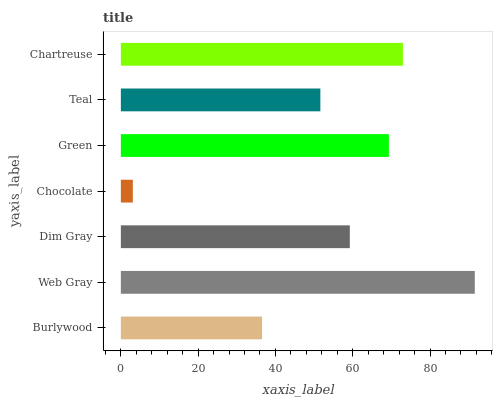Is Chocolate the minimum?
Answer yes or no. Yes. Is Web Gray the maximum?
Answer yes or no. Yes. Is Dim Gray the minimum?
Answer yes or no. No. Is Dim Gray the maximum?
Answer yes or no. No. Is Web Gray greater than Dim Gray?
Answer yes or no. Yes. Is Dim Gray less than Web Gray?
Answer yes or no. Yes. Is Dim Gray greater than Web Gray?
Answer yes or no. No. Is Web Gray less than Dim Gray?
Answer yes or no. No. Is Dim Gray the high median?
Answer yes or no. Yes. Is Dim Gray the low median?
Answer yes or no. Yes. Is Chartreuse the high median?
Answer yes or no. No. Is Burlywood the low median?
Answer yes or no. No. 